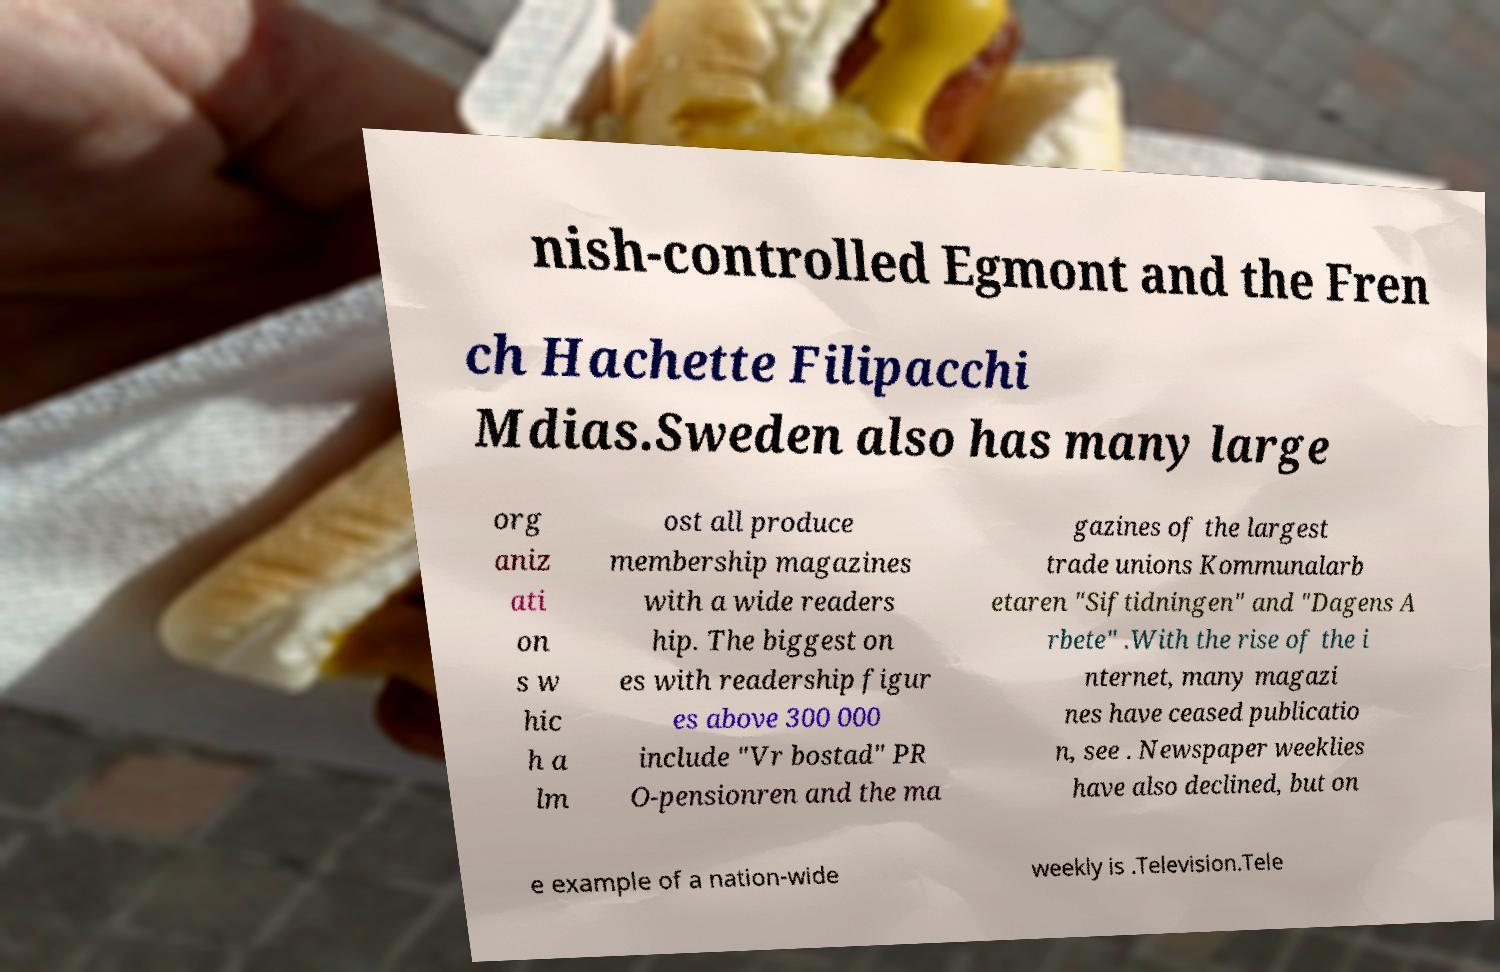There's text embedded in this image that I need extracted. Can you transcribe it verbatim? nish-controlled Egmont and the Fren ch Hachette Filipacchi Mdias.Sweden also has many large org aniz ati on s w hic h a lm ost all produce membership magazines with a wide readers hip. The biggest on es with readership figur es above 300 000 include "Vr bostad" PR O-pensionren and the ma gazines of the largest trade unions Kommunalarb etaren "Siftidningen" and "Dagens A rbete" .With the rise of the i nternet, many magazi nes have ceased publicatio n, see . Newspaper weeklies have also declined, but on e example of a nation-wide weekly is .Television.Tele 